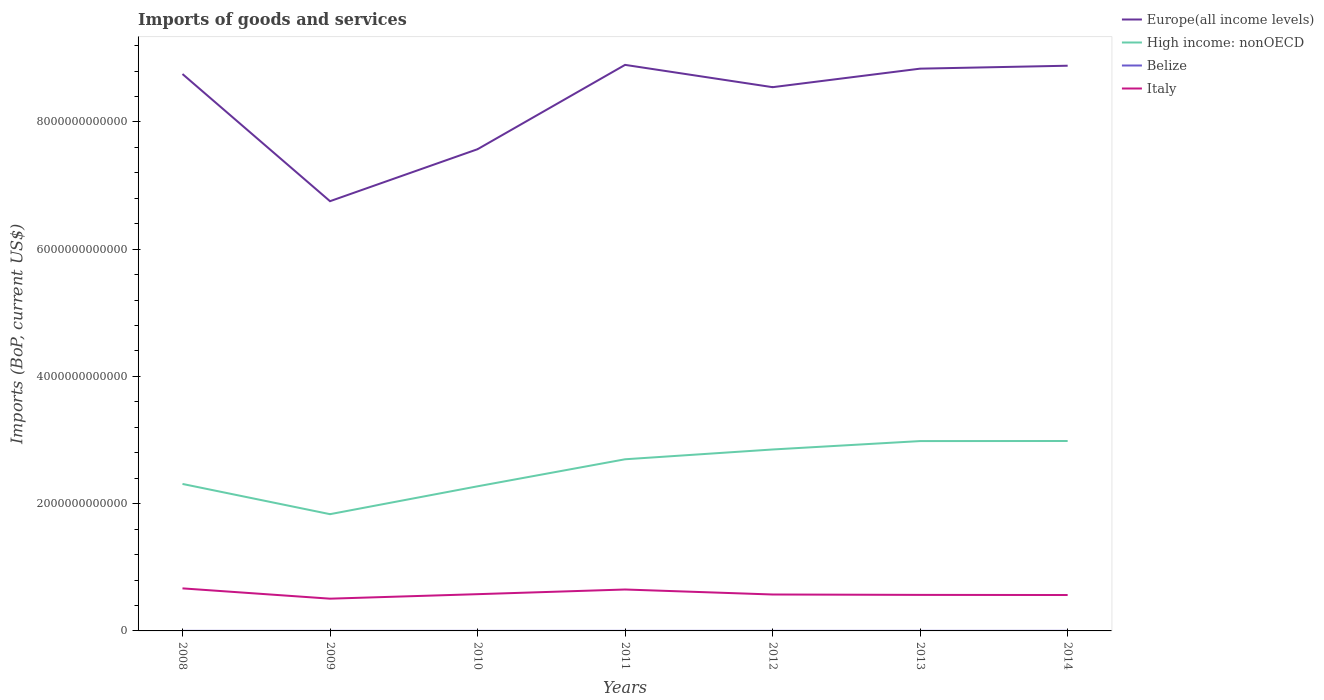Does the line corresponding to High income: nonOECD intersect with the line corresponding to Italy?
Offer a terse response. No. Across all years, what is the maximum amount spent on imports in Belize?
Make the answer very short. 7.82e+08. What is the total amount spent on imports in Belize in the graph?
Provide a succinct answer. -6.72e+07. What is the difference between the highest and the second highest amount spent on imports in High income: nonOECD?
Your answer should be very brief. 1.15e+12. What is the difference between the highest and the lowest amount spent on imports in High income: nonOECD?
Provide a short and direct response. 4. Is the amount spent on imports in High income: nonOECD strictly greater than the amount spent on imports in Italy over the years?
Ensure brevity in your answer.  No. What is the difference between two consecutive major ticks on the Y-axis?
Keep it short and to the point. 2.00e+12. Are the values on the major ticks of Y-axis written in scientific E-notation?
Your answer should be compact. No. Does the graph contain any zero values?
Your answer should be very brief. No. How many legend labels are there?
Give a very brief answer. 4. What is the title of the graph?
Your answer should be compact. Imports of goods and services. Does "East Asia (developing only)" appear as one of the legend labels in the graph?
Your response must be concise. No. What is the label or title of the X-axis?
Provide a short and direct response. Years. What is the label or title of the Y-axis?
Your response must be concise. Imports (BoP, current US$). What is the Imports (BoP, current US$) of Europe(all income levels) in 2008?
Provide a short and direct response. 8.75e+12. What is the Imports (BoP, current US$) of High income: nonOECD in 2008?
Provide a short and direct response. 2.31e+12. What is the Imports (BoP, current US$) in Belize in 2008?
Your answer should be compact. 9.58e+08. What is the Imports (BoP, current US$) of Italy in 2008?
Provide a succinct answer. 6.69e+11. What is the Imports (BoP, current US$) of Europe(all income levels) in 2009?
Your answer should be compact. 6.75e+12. What is the Imports (BoP, current US$) of High income: nonOECD in 2009?
Offer a very short reply. 1.83e+12. What is the Imports (BoP, current US$) of Belize in 2009?
Your answer should be compact. 7.82e+08. What is the Imports (BoP, current US$) of Italy in 2009?
Your response must be concise. 5.07e+11. What is the Imports (BoP, current US$) in Europe(all income levels) in 2010?
Ensure brevity in your answer.  7.57e+12. What is the Imports (BoP, current US$) in High income: nonOECD in 2010?
Provide a short and direct response. 2.27e+12. What is the Imports (BoP, current US$) of Belize in 2010?
Offer a very short reply. 8.10e+08. What is the Imports (BoP, current US$) in Italy in 2010?
Offer a terse response. 5.78e+11. What is the Imports (BoP, current US$) of Europe(all income levels) in 2011?
Keep it short and to the point. 8.90e+12. What is the Imports (BoP, current US$) of High income: nonOECD in 2011?
Keep it short and to the point. 2.70e+12. What is the Imports (BoP, current US$) in Belize in 2011?
Ensure brevity in your answer.  9.49e+08. What is the Imports (BoP, current US$) in Italy in 2011?
Provide a succinct answer. 6.51e+11. What is the Imports (BoP, current US$) in Europe(all income levels) in 2012?
Your answer should be very brief. 8.55e+12. What is the Imports (BoP, current US$) of High income: nonOECD in 2012?
Your answer should be very brief. 2.85e+12. What is the Imports (BoP, current US$) of Belize in 2012?
Make the answer very short. 1.03e+09. What is the Imports (BoP, current US$) of Italy in 2012?
Your answer should be compact. 5.72e+11. What is the Imports (BoP, current US$) of Europe(all income levels) in 2013?
Your answer should be compact. 8.84e+12. What is the Imports (BoP, current US$) in High income: nonOECD in 2013?
Give a very brief answer. 2.98e+12. What is the Imports (BoP, current US$) in Belize in 2013?
Provide a succinct answer. 1.08e+09. What is the Imports (BoP, current US$) in Italy in 2013?
Keep it short and to the point. 5.66e+11. What is the Imports (BoP, current US$) of Europe(all income levels) in 2014?
Your answer should be very brief. 8.88e+12. What is the Imports (BoP, current US$) of High income: nonOECD in 2014?
Offer a very short reply. 2.99e+12. What is the Imports (BoP, current US$) in Belize in 2014?
Your answer should be very brief. 1.15e+09. What is the Imports (BoP, current US$) of Italy in 2014?
Make the answer very short. 5.64e+11. Across all years, what is the maximum Imports (BoP, current US$) of Europe(all income levels)?
Your answer should be compact. 8.90e+12. Across all years, what is the maximum Imports (BoP, current US$) of High income: nonOECD?
Your answer should be compact. 2.99e+12. Across all years, what is the maximum Imports (BoP, current US$) in Belize?
Provide a short and direct response. 1.15e+09. Across all years, what is the maximum Imports (BoP, current US$) of Italy?
Provide a succinct answer. 6.69e+11. Across all years, what is the minimum Imports (BoP, current US$) of Europe(all income levels)?
Give a very brief answer. 6.75e+12. Across all years, what is the minimum Imports (BoP, current US$) of High income: nonOECD?
Ensure brevity in your answer.  1.83e+12. Across all years, what is the minimum Imports (BoP, current US$) in Belize?
Keep it short and to the point. 7.82e+08. Across all years, what is the minimum Imports (BoP, current US$) of Italy?
Your answer should be very brief. 5.07e+11. What is the total Imports (BoP, current US$) of Europe(all income levels) in the graph?
Keep it short and to the point. 5.82e+13. What is the total Imports (BoP, current US$) of High income: nonOECD in the graph?
Provide a short and direct response. 1.79e+13. What is the total Imports (BoP, current US$) in Belize in the graph?
Your answer should be very brief. 6.76e+09. What is the total Imports (BoP, current US$) in Italy in the graph?
Give a very brief answer. 4.11e+12. What is the difference between the Imports (BoP, current US$) of Europe(all income levels) in 2008 and that in 2009?
Your answer should be compact. 2.00e+12. What is the difference between the Imports (BoP, current US$) of High income: nonOECD in 2008 and that in 2009?
Make the answer very short. 4.75e+11. What is the difference between the Imports (BoP, current US$) of Belize in 2008 and that in 2009?
Offer a terse response. 1.76e+08. What is the difference between the Imports (BoP, current US$) in Italy in 2008 and that in 2009?
Provide a succinct answer. 1.62e+11. What is the difference between the Imports (BoP, current US$) in Europe(all income levels) in 2008 and that in 2010?
Make the answer very short. 1.18e+12. What is the difference between the Imports (BoP, current US$) of High income: nonOECD in 2008 and that in 2010?
Your answer should be very brief. 3.72e+1. What is the difference between the Imports (BoP, current US$) of Belize in 2008 and that in 2010?
Offer a very short reply. 1.48e+08. What is the difference between the Imports (BoP, current US$) of Italy in 2008 and that in 2010?
Provide a short and direct response. 9.11e+1. What is the difference between the Imports (BoP, current US$) of Europe(all income levels) in 2008 and that in 2011?
Give a very brief answer. -1.44e+11. What is the difference between the Imports (BoP, current US$) in High income: nonOECD in 2008 and that in 2011?
Your answer should be compact. -3.88e+11. What is the difference between the Imports (BoP, current US$) of Belize in 2008 and that in 2011?
Offer a very short reply. 8.56e+06. What is the difference between the Imports (BoP, current US$) in Italy in 2008 and that in 2011?
Offer a terse response. 1.76e+1. What is the difference between the Imports (BoP, current US$) in Europe(all income levels) in 2008 and that in 2012?
Your response must be concise. 2.07e+11. What is the difference between the Imports (BoP, current US$) in High income: nonOECD in 2008 and that in 2012?
Your response must be concise. -5.41e+11. What is the difference between the Imports (BoP, current US$) of Belize in 2008 and that in 2012?
Your answer should be very brief. -6.72e+07. What is the difference between the Imports (BoP, current US$) in Italy in 2008 and that in 2012?
Provide a succinct answer. 9.64e+1. What is the difference between the Imports (BoP, current US$) of Europe(all income levels) in 2008 and that in 2013?
Your answer should be very brief. -8.43e+1. What is the difference between the Imports (BoP, current US$) of High income: nonOECD in 2008 and that in 2013?
Provide a short and direct response. -6.74e+11. What is the difference between the Imports (BoP, current US$) in Belize in 2008 and that in 2013?
Give a very brief answer. -1.26e+08. What is the difference between the Imports (BoP, current US$) in Italy in 2008 and that in 2013?
Provide a succinct answer. 1.02e+11. What is the difference between the Imports (BoP, current US$) of Europe(all income levels) in 2008 and that in 2014?
Keep it short and to the point. -1.30e+11. What is the difference between the Imports (BoP, current US$) in High income: nonOECD in 2008 and that in 2014?
Offer a very short reply. -6.75e+11. What is the difference between the Imports (BoP, current US$) of Belize in 2008 and that in 2014?
Offer a terse response. -1.92e+08. What is the difference between the Imports (BoP, current US$) in Italy in 2008 and that in 2014?
Keep it short and to the point. 1.04e+11. What is the difference between the Imports (BoP, current US$) of Europe(all income levels) in 2009 and that in 2010?
Provide a short and direct response. -8.17e+11. What is the difference between the Imports (BoP, current US$) in High income: nonOECD in 2009 and that in 2010?
Provide a short and direct response. -4.38e+11. What is the difference between the Imports (BoP, current US$) in Belize in 2009 and that in 2010?
Your answer should be compact. -2.74e+07. What is the difference between the Imports (BoP, current US$) of Italy in 2009 and that in 2010?
Give a very brief answer. -7.07e+1. What is the difference between the Imports (BoP, current US$) of Europe(all income levels) in 2009 and that in 2011?
Keep it short and to the point. -2.14e+12. What is the difference between the Imports (BoP, current US$) in High income: nonOECD in 2009 and that in 2011?
Your answer should be compact. -8.63e+11. What is the difference between the Imports (BoP, current US$) in Belize in 2009 and that in 2011?
Offer a terse response. -1.67e+08. What is the difference between the Imports (BoP, current US$) in Italy in 2009 and that in 2011?
Your answer should be compact. -1.44e+11. What is the difference between the Imports (BoP, current US$) of Europe(all income levels) in 2009 and that in 2012?
Offer a terse response. -1.79e+12. What is the difference between the Imports (BoP, current US$) in High income: nonOECD in 2009 and that in 2012?
Your answer should be very brief. -1.02e+12. What is the difference between the Imports (BoP, current US$) in Belize in 2009 and that in 2012?
Provide a succinct answer. -2.43e+08. What is the difference between the Imports (BoP, current US$) in Italy in 2009 and that in 2012?
Your answer should be compact. -6.54e+1. What is the difference between the Imports (BoP, current US$) of Europe(all income levels) in 2009 and that in 2013?
Ensure brevity in your answer.  -2.08e+12. What is the difference between the Imports (BoP, current US$) of High income: nonOECD in 2009 and that in 2013?
Your answer should be very brief. -1.15e+12. What is the difference between the Imports (BoP, current US$) of Belize in 2009 and that in 2013?
Ensure brevity in your answer.  -3.01e+08. What is the difference between the Imports (BoP, current US$) in Italy in 2009 and that in 2013?
Ensure brevity in your answer.  -5.94e+1. What is the difference between the Imports (BoP, current US$) of Europe(all income levels) in 2009 and that in 2014?
Your answer should be very brief. -2.13e+12. What is the difference between the Imports (BoP, current US$) in High income: nonOECD in 2009 and that in 2014?
Provide a succinct answer. -1.15e+12. What is the difference between the Imports (BoP, current US$) in Belize in 2009 and that in 2014?
Give a very brief answer. -3.68e+08. What is the difference between the Imports (BoP, current US$) of Italy in 2009 and that in 2014?
Provide a succinct answer. -5.75e+1. What is the difference between the Imports (BoP, current US$) of Europe(all income levels) in 2010 and that in 2011?
Offer a terse response. -1.33e+12. What is the difference between the Imports (BoP, current US$) in High income: nonOECD in 2010 and that in 2011?
Your response must be concise. -4.25e+11. What is the difference between the Imports (BoP, current US$) of Belize in 2010 and that in 2011?
Ensure brevity in your answer.  -1.40e+08. What is the difference between the Imports (BoP, current US$) in Italy in 2010 and that in 2011?
Offer a terse response. -7.35e+1. What is the difference between the Imports (BoP, current US$) in Europe(all income levels) in 2010 and that in 2012?
Ensure brevity in your answer.  -9.75e+11. What is the difference between the Imports (BoP, current US$) of High income: nonOECD in 2010 and that in 2012?
Offer a terse response. -5.79e+11. What is the difference between the Imports (BoP, current US$) in Belize in 2010 and that in 2012?
Your answer should be compact. -2.15e+08. What is the difference between the Imports (BoP, current US$) of Italy in 2010 and that in 2012?
Ensure brevity in your answer.  5.26e+09. What is the difference between the Imports (BoP, current US$) in Europe(all income levels) in 2010 and that in 2013?
Your response must be concise. -1.27e+12. What is the difference between the Imports (BoP, current US$) of High income: nonOECD in 2010 and that in 2013?
Your answer should be compact. -7.11e+11. What is the difference between the Imports (BoP, current US$) of Belize in 2010 and that in 2013?
Provide a succinct answer. -2.74e+08. What is the difference between the Imports (BoP, current US$) of Italy in 2010 and that in 2013?
Keep it short and to the point. 1.13e+1. What is the difference between the Imports (BoP, current US$) of Europe(all income levels) in 2010 and that in 2014?
Your answer should be compact. -1.31e+12. What is the difference between the Imports (BoP, current US$) of High income: nonOECD in 2010 and that in 2014?
Your answer should be very brief. -7.12e+11. What is the difference between the Imports (BoP, current US$) of Belize in 2010 and that in 2014?
Offer a very short reply. -3.41e+08. What is the difference between the Imports (BoP, current US$) in Italy in 2010 and that in 2014?
Offer a terse response. 1.32e+1. What is the difference between the Imports (BoP, current US$) of Europe(all income levels) in 2011 and that in 2012?
Your answer should be compact. 3.51e+11. What is the difference between the Imports (BoP, current US$) of High income: nonOECD in 2011 and that in 2012?
Offer a terse response. -1.54e+11. What is the difference between the Imports (BoP, current US$) of Belize in 2011 and that in 2012?
Your answer should be compact. -7.58e+07. What is the difference between the Imports (BoP, current US$) in Italy in 2011 and that in 2012?
Your answer should be very brief. 7.88e+1. What is the difference between the Imports (BoP, current US$) in Europe(all income levels) in 2011 and that in 2013?
Make the answer very short. 5.94e+1. What is the difference between the Imports (BoP, current US$) in High income: nonOECD in 2011 and that in 2013?
Give a very brief answer. -2.86e+11. What is the difference between the Imports (BoP, current US$) in Belize in 2011 and that in 2013?
Your response must be concise. -1.34e+08. What is the difference between the Imports (BoP, current US$) of Italy in 2011 and that in 2013?
Your answer should be compact. 8.48e+1. What is the difference between the Imports (BoP, current US$) of Europe(all income levels) in 2011 and that in 2014?
Offer a terse response. 1.32e+1. What is the difference between the Imports (BoP, current US$) in High income: nonOECD in 2011 and that in 2014?
Your response must be concise. -2.87e+11. What is the difference between the Imports (BoP, current US$) in Belize in 2011 and that in 2014?
Make the answer very short. -2.01e+08. What is the difference between the Imports (BoP, current US$) in Italy in 2011 and that in 2014?
Provide a succinct answer. 8.67e+1. What is the difference between the Imports (BoP, current US$) of Europe(all income levels) in 2012 and that in 2013?
Keep it short and to the point. -2.91e+11. What is the difference between the Imports (BoP, current US$) of High income: nonOECD in 2012 and that in 2013?
Your response must be concise. -1.32e+11. What is the difference between the Imports (BoP, current US$) in Belize in 2012 and that in 2013?
Provide a succinct answer. -5.86e+07. What is the difference between the Imports (BoP, current US$) of Italy in 2012 and that in 2013?
Keep it short and to the point. 6.00e+09. What is the difference between the Imports (BoP, current US$) of Europe(all income levels) in 2012 and that in 2014?
Your response must be concise. -3.37e+11. What is the difference between the Imports (BoP, current US$) of High income: nonOECD in 2012 and that in 2014?
Provide a succinct answer. -1.33e+11. What is the difference between the Imports (BoP, current US$) of Belize in 2012 and that in 2014?
Ensure brevity in your answer.  -1.25e+08. What is the difference between the Imports (BoP, current US$) of Italy in 2012 and that in 2014?
Offer a very short reply. 7.92e+09. What is the difference between the Imports (BoP, current US$) in Europe(all income levels) in 2013 and that in 2014?
Ensure brevity in your answer.  -4.62e+1. What is the difference between the Imports (BoP, current US$) of High income: nonOECD in 2013 and that in 2014?
Your answer should be compact. -1.19e+09. What is the difference between the Imports (BoP, current US$) of Belize in 2013 and that in 2014?
Your response must be concise. -6.64e+07. What is the difference between the Imports (BoP, current US$) of Italy in 2013 and that in 2014?
Keep it short and to the point. 1.92e+09. What is the difference between the Imports (BoP, current US$) of Europe(all income levels) in 2008 and the Imports (BoP, current US$) of High income: nonOECD in 2009?
Your response must be concise. 6.92e+12. What is the difference between the Imports (BoP, current US$) of Europe(all income levels) in 2008 and the Imports (BoP, current US$) of Belize in 2009?
Provide a succinct answer. 8.75e+12. What is the difference between the Imports (BoP, current US$) of Europe(all income levels) in 2008 and the Imports (BoP, current US$) of Italy in 2009?
Provide a short and direct response. 8.25e+12. What is the difference between the Imports (BoP, current US$) in High income: nonOECD in 2008 and the Imports (BoP, current US$) in Belize in 2009?
Your answer should be very brief. 2.31e+12. What is the difference between the Imports (BoP, current US$) in High income: nonOECD in 2008 and the Imports (BoP, current US$) in Italy in 2009?
Your response must be concise. 1.80e+12. What is the difference between the Imports (BoP, current US$) in Belize in 2008 and the Imports (BoP, current US$) in Italy in 2009?
Give a very brief answer. -5.06e+11. What is the difference between the Imports (BoP, current US$) in Europe(all income levels) in 2008 and the Imports (BoP, current US$) in High income: nonOECD in 2010?
Give a very brief answer. 6.48e+12. What is the difference between the Imports (BoP, current US$) in Europe(all income levels) in 2008 and the Imports (BoP, current US$) in Belize in 2010?
Offer a terse response. 8.75e+12. What is the difference between the Imports (BoP, current US$) of Europe(all income levels) in 2008 and the Imports (BoP, current US$) of Italy in 2010?
Your answer should be compact. 8.18e+12. What is the difference between the Imports (BoP, current US$) of High income: nonOECD in 2008 and the Imports (BoP, current US$) of Belize in 2010?
Provide a succinct answer. 2.31e+12. What is the difference between the Imports (BoP, current US$) in High income: nonOECD in 2008 and the Imports (BoP, current US$) in Italy in 2010?
Provide a succinct answer. 1.73e+12. What is the difference between the Imports (BoP, current US$) in Belize in 2008 and the Imports (BoP, current US$) in Italy in 2010?
Your answer should be compact. -5.77e+11. What is the difference between the Imports (BoP, current US$) of Europe(all income levels) in 2008 and the Imports (BoP, current US$) of High income: nonOECD in 2011?
Your response must be concise. 6.06e+12. What is the difference between the Imports (BoP, current US$) of Europe(all income levels) in 2008 and the Imports (BoP, current US$) of Belize in 2011?
Provide a succinct answer. 8.75e+12. What is the difference between the Imports (BoP, current US$) of Europe(all income levels) in 2008 and the Imports (BoP, current US$) of Italy in 2011?
Your response must be concise. 8.10e+12. What is the difference between the Imports (BoP, current US$) of High income: nonOECD in 2008 and the Imports (BoP, current US$) of Belize in 2011?
Offer a terse response. 2.31e+12. What is the difference between the Imports (BoP, current US$) of High income: nonOECD in 2008 and the Imports (BoP, current US$) of Italy in 2011?
Your answer should be compact. 1.66e+12. What is the difference between the Imports (BoP, current US$) of Belize in 2008 and the Imports (BoP, current US$) of Italy in 2011?
Offer a very short reply. -6.50e+11. What is the difference between the Imports (BoP, current US$) in Europe(all income levels) in 2008 and the Imports (BoP, current US$) in High income: nonOECD in 2012?
Provide a short and direct response. 5.90e+12. What is the difference between the Imports (BoP, current US$) in Europe(all income levels) in 2008 and the Imports (BoP, current US$) in Belize in 2012?
Your answer should be very brief. 8.75e+12. What is the difference between the Imports (BoP, current US$) in Europe(all income levels) in 2008 and the Imports (BoP, current US$) in Italy in 2012?
Give a very brief answer. 8.18e+12. What is the difference between the Imports (BoP, current US$) in High income: nonOECD in 2008 and the Imports (BoP, current US$) in Belize in 2012?
Keep it short and to the point. 2.31e+12. What is the difference between the Imports (BoP, current US$) of High income: nonOECD in 2008 and the Imports (BoP, current US$) of Italy in 2012?
Your answer should be compact. 1.74e+12. What is the difference between the Imports (BoP, current US$) in Belize in 2008 and the Imports (BoP, current US$) in Italy in 2012?
Your response must be concise. -5.71e+11. What is the difference between the Imports (BoP, current US$) of Europe(all income levels) in 2008 and the Imports (BoP, current US$) of High income: nonOECD in 2013?
Provide a short and direct response. 5.77e+12. What is the difference between the Imports (BoP, current US$) in Europe(all income levels) in 2008 and the Imports (BoP, current US$) in Belize in 2013?
Your answer should be very brief. 8.75e+12. What is the difference between the Imports (BoP, current US$) of Europe(all income levels) in 2008 and the Imports (BoP, current US$) of Italy in 2013?
Keep it short and to the point. 8.19e+12. What is the difference between the Imports (BoP, current US$) in High income: nonOECD in 2008 and the Imports (BoP, current US$) in Belize in 2013?
Your response must be concise. 2.31e+12. What is the difference between the Imports (BoP, current US$) of High income: nonOECD in 2008 and the Imports (BoP, current US$) of Italy in 2013?
Offer a very short reply. 1.74e+12. What is the difference between the Imports (BoP, current US$) in Belize in 2008 and the Imports (BoP, current US$) in Italy in 2013?
Keep it short and to the point. -5.65e+11. What is the difference between the Imports (BoP, current US$) in Europe(all income levels) in 2008 and the Imports (BoP, current US$) in High income: nonOECD in 2014?
Keep it short and to the point. 5.77e+12. What is the difference between the Imports (BoP, current US$) in Europe(all income levels) in 2008 and the Imports (BoP, current US$) in Belize in 2014?
Your answer should be very brief. 8.75e+12. What is the difference between the Imports (BoP, current US$) in Europe(all income levels) in 2008 and the Imports (BoP, current US$) in Italy in 2014?
Offer a terse response. 8.19e+12. What is the difference between the Imports (BoP, current US$) in High income: nonOECD in 2008 and the Imports (BoP, current US$) in Belize in 2014?
Provide a short and direct response. 2.31e+12. What is the difference between the Imports (BoP, current US$) of High income: nonOECD in 2008 and the Imports (BoP, current US$) of Italy in 2014?
Make the answer very short. 1.75e+12. What is the difference between the Imports (BoP, current US$) in Belize in 2008 and the Imports (BoP, current US$) in Italy in 2014?
Provide a short and direct response. -5.63e+11. What is the difference between the Imports (BoP, current US$) in Europe(all income levels) in 2009 and the Imports (BoP, current US$) in High income: nonOECD in 2010?
Keep it short and to the point. 4.48e+12. What is the difference between the Imports (BoP, current US$) of Europe(all income levels) in 2009 and the Imports (BoP, current US$) of Belize in 2010?
Provide a short and direct response. 6.75e+12. What is the difference between the Imports (BoP, current US$) in Europe(all income levels) in 2009 and the Imports (BoP, current US$) in Italy in 2010?
Your answer should be very brief. 6.18e+12. What is the difference between the Imports (BoP, current US$) in High income: nonOECD in 2009 and the Imports (BoP, current US$) in Belize in 2010?
Keep it short and to the point. 1.83e+12. What is the difference between the Imports (BoP, current US$) in High income: nonOECD in 2009 and the Imports (BoP, current US$) in Italy in 2010?
Offer a very short reply. 1.26e+12. What is the difference between the Imports (BoP, current US$) of Belize in 2009 and the Imports (BoP, current US$) of Italy in 2010?
Keep it short and to the point. -5.77e+11. What is the difference between the Imports (BoP, current US$) in Europe(all income levels) in 2009 and the Imports (BoP, current US$) in High income: nonOECD in 2011?
Ensure brevity in your answer.  4.06e+12. What is the difference between the Imports (BoP, current US$) of Europe(all income levels) in 2009 and the Imports (BoP, current US$) of Belize in 2011?
Offer a very short reply. 6.75e+12. What is the difference between the Imports (BoP, current US$) in Europe(all income levels) in 2009 and the Imports (BoP, current US$) in Italy in 2011?
Your response must be concise. 6.10e+12. What is the difference between the Imports (BoP, current US$) in High income: nonOECD in 2009 and the Imports (BoP, current US$) in Belize in 2011?
Your answer should be very brief. 1.83e+12. What is the difference between the Imports (BoP, current US$) of High income: nonOECD in 2009 and the Imports (BoP, current US$) of Italy in 2011?
Offer a terse response. 1.18e+12. What is the difference between the Imports (BoP, current US$) in Belize in 2009 and the Imports (BoP, current US$) in Italy in 2011?
Give a very brief answer. -6.50e+11. What is the difference between the Imports (BoP, current US$) of Europe(all income levels) in 2009 and the Imports (BoP, current US$) of High income: nonOECD in 2012?
Offer a very short reply. 3.90e+12. What is the difference between the Imports (BoP, current US$) in Europe(all income levels) in 2009 and the Imports (BoP, current US$) in Belize in 2012?
Give a very brief answer. 6.75e+12. What is the difference between the Imports (BoP, current US$) in Europe(all income levels) in 2009 and the Imports (BoP, current US$) in Italy in 2012?
Give a very brief answer. 6.18e+12. What is the difference between the Imports (BoP, current US$) in High income: nonOECD in 2009 and the Imports (BoP, current US$) in Belize in 2012?
Provide a short and direct response. 1.83e+12. What is the difference between the Imports (BoP, current US$) in High income: nonOECD in 2009 and the Imports (BoP, current US$) in Italy in 2012?
Ensure brevity in your answer.  1.26e+12. What is the difference between the Imports (BoP, current US$) in Belize in 2009 and the Imports (BoP, current US$) in Italy in 2012?
Make the answer very short. -5.72e+11. What is the difference between the Imports (BoP, current US$) of Europe(all income levels) in 2009 and the Imports (BoP, current US$) of High income: nonOECD in 2013?
Offer a terse response. 3.77e+12. What is the difference between the Imports (BoP, current US$) of Europe(all income levels) in 2009 and the Imports (BoP, current US$) of Belize in 2013?
Keep it short and to the point. 6.75e+12. What is the difference between the Imports (BoP, current US$) in Europe(all income levels) in 2009 and the Imports (BoP, current US$) in Italy in 2013?
Your answer should be compact. 6.19e+12. What is the difference between the Imports (BoP, current US$) in High income: nonOECD in 2009 and the Imports (BoP, current US$) in Belize in 2013?
Make the answer very short. 1.83e+12. What is the difference between the Imports (BoP, current US$) in High income: nonOECD in 2009 and the Imports (BoP, current US$) in Italy in 2013?
Offer a terse response. 1.27e+12. What is the difference between the Imports (BoP, current US$) of Belize in 2009 and the Imports (BoP, current US$) of Italy in 2013?
Provide a short and direct response. -5.66e+11. What is the difference between the Imports (BoP, current US$) in Europe(all income levels) in 2009 and the Imports (BoP, current US$) in High income: nonOECD in 2014?
Your answer should be very brief. 3.77e+12. What is the difference between the Imports (BoP, current US$) in Europe(all income levels) in 2009 and the Imports (BoP, current US$) in Belize in 2014?
Your response must be concise. 6.75e+12. What is the difference between the Imports (BoP, current US$) of Europe(all income levels) in 2009 and the Imports (BoP, current US$) of Italy in 2014?
Provide a succinct answer. 6.19e+12. What is the difference between the Imports (BoP, current US$) in High income: nonOECD in 2009 and the Imports (BoP, current US$) in Belize in 2014?
Offer a terse response. 1.83e+12. What is the difference between the Imports (BoP, current US$) in High income: nonOECD in 2009 and the Imports (BoP, current US$) in Italy in 2014?
Give a very brief answer. 1.27e+12. What is the difference between the Imports (BoP, current US$) of Belize in 2009 and the Imports (BoP, current US$) of Italy in 2014?
Your response must be concise. -5.64e+11. What is the difference between the Imports (BoP, current US$) in Europe(all income levels) in 2010 and the Imports (BoP, current US$) in High income: nonOECD in 2011?
Your response must be concise. 4.87e+12. What is the difference between the Imports (BoP, current US$) of Europe(all income levels) in 2010 and the Imports (BoP, current US$) of Belize in 2011?
Make the answer very short. 7.57e+12. What is the difference between the Imports (BoP, current US$) of Europe(all income levels) in 2010 and the Imports (BoP, current US$) of Italy in 2011?
Ensure brevity in your answer.  6.92e+12. What is the difference between the Imports (BoP, current US$) of High income: nonOECD in 2010 and the Imports (BoP, current US$) of Belize in 2011?
Your answer should be very brief. 2.27e+12. What is the difference between the Imports (BoP, current US$) in High income: nonOECD in 2010 and the Imports (BoP, current US$) in Italy in 2011?
Keep it short and to the point. 1.62e+12. What is the difference between the Imports (BoP, current US$) in Belize in 2010 and the Imports (BoP, current US$) in Italy in 2011?
Provide a short and direct response. -6.50e+11. What is the difference between the Imports (BoP, current US$) in Europe(all income levels) in 2010 and the Imports (BoP, current US$) in High income: nonOECD in 2012?
Provide a short and direct response. 4.72e+12. What is the difference between the Imports (BoP, current US$) of Europe(all income levels) in 2010 and the Imports (BoP, current US$) of Belize in 2012?
Offer a terse response. 7.57e+12. What is the difference between the Imports (BoP, current US$) of Europe(all income levels) in 2010 and the Imports (BoP, current US$) of Italy in 2012?
Your answer should be compact. 7.00e+12. What is the difference between the Imports (BoP, current US$) of High income: nonOECD in 2010 and the Imports (BoP, current US$) of Belize in 2012?
Your answer should be very brief. 2.27e+12. What is the difference between the Imports (BoP, current US$) of High income: nonOECD in 2010 and the Imports (BoP, current US$) of Italy in 2012?
Your answer should be very brief. 1.70e+12. What is the difference between the Imports (BoP, current US$) in Belize in 2010 and the Imports (BoP, current US$) in Italy in 2012?
Give a very brief answer. -5.72e+11. What is the difference between the Imports (BoP, current US$) in Europe(all income levels) in 2010 and the Imports (BoP, current US$) in High income: nonOECD in 2013?
Keep it short and to the point. 4.59e+12. What is the difference between the Imports (BoP, current US$) in Europe(all income levels) in 2010 and the Imports (BoP, current US$) in Belize in 2013?
Your answer should be very brief. 7.57e+12. What is the difference between the Imports (BoP, current US$) of Europe(all income levels) in 2010 and the Imports (BoP, current US$) of Italy in 2013?
Your response must be concise. 7.00e+12. What is the difference between the Imports (BoP, current US$) in High income: nonOECD in 2010 and the Imports (BoP, current US$) in Belize in 2013?
Make the answer very short. 2.27e+12. What is the difference between the Imports (BoP, current US$) in High income: nonOECD in 2010 and the Imports (BoP, current US$) in Italy in 2013?
Provide a succinct answer. 1.71e+12. What is the difference between the Imports (BoP, current US$) in Belize in 2010 and the Imports (BoP, current US$) in Italy in 2013?
Keep it short and to the point. -5.66e+11. What is the difference between the Imports (BoP, current US$) of Europe(all income levels) in 2010 and the Imports (BoP, current US$) of High income: nonOECD in 2014?
Ensure brevity in your answer.  4.59e+12. What is the difference between the Imports (BoP, current US$) of Europe(all income levels) in 2010 and the Imports (BoP, current US$) of Belize in 2014?
Your answer should be compact. 7.57e+12. What is the difference between the Imports (BoP, current US$) in Europe(all income levels) in 2010 and the Imports (BoP, current US$) in Italy in 2014?
Your response must be concise. 7.01e+12. What is the difference between the Imports (BoP, current US$) in High income: nonOECD in 2010 and the Imports (BoP, current US$) in Belize in 2014?
Offer a very short reply. 2.27e+12. What is the difference between the Imports (BoP, current US$) in High income: nonOECD in 2010 and the Imports (BoP, current US$) in Italy in 2014?
Offer a terse response. 1.71e+12. What is the difference between the Imports (BoP, current US$) of Belize in 2010 and the Imports (BoP, current US$) of Italy in 2014?
Your answer should be very brief. -5.64e+11. What is the difference between the Imports (BoP, current US$) of Europe(all income levels) in 2011 and the Imports (BoP, current US$) of High income: nonOECD in 2012?
Offer a very short reply. 6.05e+12. What is the difference between the Imports (BoP, current US$) of Europe(all income levels) in 2011 and the Imports (BoP, current US$) of Belize in 2012?
Ensure brevity in your answer.  8.90e+12. What is the difference between the Imports (BoP, current US$) of Europe(all income levels) in 2011 and the Imports (BoP, current US$) of Italy in 2012?
Give a very brief answer. 8.32e+12. What is the difference between the Imports (BoP, current US$) in High income: nonOECD in 2011 and the Imports (BoP, current US$) in Belize in 2012?
Provide a short and direct response. 2.70e+12. What is the difference between the Imports (BoP, current US$) in High income: nonOECD in 2011 and the Imports (BoP, current US$) in Italy in 2012?
Ensure brevity in your answer.  2.13e+12. What is the difference between the Imports (BoP, current US$) of Belize in 2011 and the Imports (BoP, current US$) of Italy in 2012?
Give a very brief answer. -5.71e+11. What is the difference between the Imports (BoP, current US$) of Europe(all income levels) in 2011 and the Imports (BoP, current US$) of High income: nonOECD in 2013?
Make the answer very short. 5.91e+12. What is the difference between the Imports (BoP, current US$) in Europe(all income levels) in 2011 and the Imports (BoP, current US$) in Belize in 2013?
Make the answer very short. 8.90e+12. What is the difference between the Imports (BoP, current US$) in Europe(all income levels) in 2011 and the Imports (BoP, current US$) in Italy in 2013?
Offer a terse response. 8.33e+12. What is the difference between the Imports (BoP, current US$) in High income: nonOECD in 2011 and the Imports (BoP, current US$) in Belize in 2013?
Your response must be concise. 2.70e+12. What is the difference between the Imports (BoP, current US$) of High income: nonOECD in 2011 and the Imports (BoP, current US$) of Italy in 2013?
Give a very brief answer. 2.13e+12. What is the difference between the Imports (BoP, current US$) in Belize in 2011 and the Imports (BoP, current US$) in Italy in 2013?
Keep it short and to the point. -5.65e+11. What is the difference between the Imports (BoP, current US$) in Europe(all income levels) in 2011 and the Imports (BoP, current US$) in High income: nonOECD in 2014?
Provide a short and direct response. 5.91e+12. What is the difference between the Imports (BoP, current US$) of Europe(all income levels) in 2011 and the Imports (BoP, current US$) of Belize in 2014?
Make the answer very short. 8.90e+12. What is the difference between the Imports (BoP, current US$) of Europe(all income levels) in 2011 and the Imports (BoP, current US$) of Italy in 2014?
Provide a short and direct response. 8.33e+12. What is the difference between the Imports (BoP, current US$) in High income: nonOECD in 2011 and the Imports (BoP, current US$) in Belize in 2014?
Your answer should be very brief. 2.70e+12. What is the difference between the Imports (BoP, current US$) of High income: nonOECD in 2011 and the Imports (BoP, current US$) of Italy in 2014?
Your answer should be very brief. 2.13e+12. What is the difference between the Imports (BoP, current US$) in Belize in 2011 and the Imports (BoP, current US$) in Italy in 2014?
Give a very brief answer. -5.63e+11. What is the difference between the Imports (BoP, current US$) of Europe(all income levels) in 2012 and the Imports (BoP, current US$) of High income: nonOECD in 2013?
Provide a short and direct response. 5.56e+12. What is the difference between the Imports (BoP, current US$) in Europe(all income levels) in 2012 and the Imports (BoP, current US$) in Belize in 2013?
Your response must be concise. 8.55e+12. What is the difference between the Imports (BoP, current US$) of Europe(all income levels) in 2012 and the Imports (BoP, current US$) of Italy in 2013?
Provide a succinct answer. 7.98e+12. What is the difference between the Imports (BoP, current US$) of High income: nonOECD in 2012 and the Imports (BoP, current US$) of Belize in 2013?
Provide a short and direct response. 2.85e+12. What is the difference between the Imports (BoP, current US$) in High income: nonOECD in 2012 and the Imports (BoP, current US$) in Italy in 2013?
Provide a succinct answer. 2.29e+12. What is the difference between the Imports (BoP, current US$) of Belize in 2012 and the Imports (BoP, current US$) of Italy in 2013?
Your answer should be very brief. -5.65e+11. What is the difference between the Imports (BoP, current US$) in Europe(all income levels) in 2012 and the Imports (BoP, current US$) in High income: nonOECD in 2014?
Your response must be concise. 5.56e+12. What is the difference between the Imports (BoP, current US$) of Europe(all income levels) in 2012 and the Imports (BoP, current US$) of Belize in 2014?
Make the answer very short. 8.54e+12. What is the difference between the Imports (BoP, current US$) in Europe(all income levels) in 2012 and the Imports (BoP, current US$) in Italy in 2014?
Offer a terse response. 7.98e+12. What is the difference between the Imports (BoP, current US$) of High income: nonOECD in 2012 and the Imports (BoP, current US$) of Belize in 2014?
Provide a succinct answer. 2.85e+12. What is the difference between the Imports (BoP, current US$) of High income: nonOECD in 2012 and the Imports (BoP, current US$) of Italy in 2014?
Provide a short and direct response. 2.29e+12. What is the difference between the Imports (BoP, current US$) of Belize in 2012 and the Imports (BoP, current US$) of Italy in 2014?
Offer a very short reply. -5.63e+11. What is the difference between the Imports (BoP, current US$) in Europe(all income levels) in 2013 and the Imports (BoP, current US$) in High income: nonOECD in 2014?
Provide a short and direct response. 5.85e+12. What is the difference between the Imports (BoP, current US$) of Europe(all income levels) in 2013 and the Imports (BoP, current US$) of Belize in 2014?
Your response must be concise. 8.84e+12. What is the difference between the Imports (BoP, current US$) in Europe(all income levels) in 2013 and the Imports (BoP, current US$) in Italy in 2014?
Offer a very short reply. 8.27e+12. What is the difference between the Imports (BoP, current US$) of High income: nonOECD in 2013 and the Imports (BoP, current US$) of Belize in 2014?
Provide a succinct answer. 2.98e+12. What is the difference between the Imports (BoP, current US$) of High income: nonOECD in 2013 and the Imports (BoP, current US$) of Italy in 2014?
Keep it short and to the point. 2.42e+12. What is the difference between the Imports (BoP, current US$) of Belize in 2013 and the Imports (BoP, current US$) of Italy in 2014?
Keep it short and to the point. -5.63e+11. What is the average Imports (BoP, current US$) in Europe(all income levels) per year?
Your answer should be compact. 8.32e+12. What is the average Imports (BoP, current US$) in High income: nonOECD per year?
Give a very brief answer. 2.56e+12. What is the average Imports (BoP, current US$) of Belize per year?
Provide a succinct answer. 9.65e+08. What is the average Imports (BoP, current US$) of Italy per year?
Offer a terse response. 5.87e+11. In the year 2008, what is the difference between the Imports (BoP, current US$) in Europe(all income levels) and Imports (BoP, current US$) in High income: nonOECD?
Offer a very short reply. 6.44e+12. In the year 2008, what is the difference between the Imports (BoP, current US$) of Europe(all income levels) and Imports (BoP, current US$) of Belize?
Give a very brief answer. 8.75e+12. In the year 2008, what is the difference between the Imports (BoP, current US$) in Europe(all income levels) and Imports (BoP, current US$) in Italy?
Your answer should be very brief. 8.08e+12. In the year 2008, what is the difference between the Imports (BoP, current US$) in High income: nonOECD and Imports (BoP, current US$) in Belize?
Offer a terse response. 2.31e+12. In the year 2008, what is the difference between the Imports (BoP, current US$) of High income: nonOECD and Imports (BoP, current US$) of Italy?
Provide a succinct answer. 1.64e+12. In the year 2008, what is the difference between the Imports (BoP, current US$) of Belize and Imports (BoP, current US$) of Italy?
Provide a succinct answer. -6.68e+11. In the year 2009, what is the difference between the Imports (BoP, current US$) of Europe(all income levels) and Imports (BoP, current US$) of High income: nonOECD?
Your answer should be very brief. 4.92e+12. In the year 2009, what is the difference between the Imports (BoP, current US$) in Europe(all income levels) and Imports (BoP, current US$) in Belize?
Your response must be concise. 6.75e+12. In the year 2009, what is the difference between the Imports (BoP, current US$) of Europe(all income levels) and Imports (BoP, current US$) of Italy?
Your response must be concise. 6.25e+12. In the year 2009, what is the difference between the Imports (BoP, current US$) in High income: nonOECD and Imports (BoP, current US$) in Belize?
Offer a terse response. 1.83e+12. In the year 2009, what is the difference between the Imports (BoP, current US$) in High income: nonOECD and Imports (BoP, current US$) in Italy?
Offer a terse response. 1.33e+12. In the year 2009, what is the difference between the Imports (BoP, current US$) in Belize and Imports (BoP, current US$) in Italy?
Offer a terse response. -5.06e+11. In the year 2010, what is the difference between the Imports (BoP, current US$) in Europe(all income levels) and Imports (BoP, current US$) in High income: nonOECD?
Provide a short and direct response. 5.30e+12. In the year 2010, what is the difference between the Imports (BoP, current US$) of Europe(all income levels) and Imports (BoP, current US$) of Belize?
Make the answer very short. 7.57e+12. In the year 2010, what is the difference between the Imports (BoP, current US$) in Europe(all income levels) and Imports (BoP, current US$) in Italy?
Your answer should be compact. 6.99e+12. In the year 2010, what is the difference between the Imports (BoP, current US$) in High income: nonOECD and Imports (BoP, current US$) in Belize?
Offer a terse response. 2.27e+12. In the year 2010, what is the difference between the Imports (BoP, current US$) of High income: nonOECD and Imports (BoP, current US$) of Italy?
Your response must be concise. 1.70e+12. In the year 2010, what is the difference between the Imports (BoP, current US$) in Belize and Imports (BoP, current US$) in Italy?
Keep it short and to the point. -5.77e+11. In the year 2011, what is the difference between the Imports (BoP, current US$) in Europe(all income levels) and Imports (BoP, current US$) in High income: nonOECD?
Keep it short and to the point. 6.20e+12. In the year 2011, what is the difference between the Imports (BoP, current US$) in Europe(all income levels) and Imports (BoP, current US$) in Belize?
Give a very brief answer. 8.90e+12. In the year 2011, what is the difference between the Imports (BoP, current US$) in Europe(all income levels) and Imports (BoP, current US$) in Italy?
Make the answer very short. 8.25e+12. In the year 2011, what is the difference between the Imports (BoP, current US$) of High income: nonOECD and Imports (BoP, current US$) of Belize?
Provide a short and direct response. 2.70e+12. In the year 2011, what is the difference between the Imports (BoP, current US$) in High income: nonOECD and Imports (BoP, current US$) in Italy?
Offer a terse response. 2.05e+12. In the year 2011, what is the difference between the Imports (BoP, current US$) of Belize and Imports (BoP, current US$) of Italy?
Ensure brevity in your answer.  -6.50e+11. In the year 2012, what is the difference between the Imports (BoP, current US$) of Europe(all income levels) and Imports (BoP, current US$) of High income: nonOECD?
Give a very brief answer. 5.69e+12. In the year 2012, what is the difference between the Imports (BoP, current US$) in Europe(all income levels) and Imports (BoP, current US$) in Belize?
Keep it short and to the point. 8.55e+12. In the year 2012, what is the difference between the Imports (BoP, current US$) in Europe(all income levels) and Imports (BoP, current US$) in Italy?
Make the answer very short. 7.97e+12. In the year 2012, what is the difference between the Imports (BoP, current US$) of High income: nonOECD and Imports (BoP, current US$) of Belize?
Offer a very short reply. 2.85e+12. In the year 2012, what is the difference between the Imports (BoP, current US$) in High income: nonOECD and Imports (BoP, current US$) in Italy?
Make the answer very short. 2.28e+12. In the year 2012, what is the difference between the Imports (BoP, current US$) of Belize and Imports (BoP, current US$) of Italy?
Give a very brief answer. -5.71e+11. In the year 2013, what is the difference between the Imports (BoP, current US$) of Europe(all income levels) and Imports (BoP, current US$) of High income: nonOECD?
Ensure brevity in your answer.  5.85e+12. In the year 2013, what is the difference between the Imports (BoP, current US$) of Europe(all income levels) and Imports (BoP, current US$) of Belize?
Ensure brevity in your answer.  8.84e+12. In the year 2013, what is the difference between the Imports (BoP, current US$) of Europe(all income levels) and Imports (BoP, current US$) of Italy?
Your response must be concise. 8.27e+12. In the year 2013, what is the difference between the Imports (BoP, current US$) in High income: nonOECD and Imports (BoP, current US$) in Belize?
Your response must be concise. 2.98e+12. In the year 2013, what is the difference between the Imports (BoP, current US$) in High income: nonOECD and Imports (BoP, current US$) in Italy?
Keep it short and to the point. 2.42e+12. In the year 2013, what is the difference between the Imports (BoP, current US$) of Belize and Imports (BoP, current US$) of Italy?
Ensure brevity in your answer.  -5.65e+11. In the year 2014, what is the difference between the Imports (BoP, current US$) of Europe(all income levels) and Imports (BoP, current US$) of High income: nonOECD?
Provide a short and direct response. 5.90e+12. In the year 2014, what is the difference between the Imports (BoP, current US$) in Europe(all income levels) and Imports (BoP, current US$) in Belize?
Offer a terse response. 8.88e+12. In the year 2014, what is the difference between the Imports (BoP, current US$) in Europe(all income levels) and Imports (BoP, current US$) in Italy?
Keep it short and to the point. 8.32e+12. In the year 2014, what is the difference between the Imports (BoP, current US$) in High income: nonOECD and Imports (BoP, current US$) in Belize?
Your answer should be very brief. 2.98e+12. In the year 2014, what is the difference between the Imports (BoP, current US$) in High income: nonOECD and Imports (BoP, current US$) in Italy?
Offer a very short reply. 2.42e+12. In the year 2014, what is the difference between the Imports (BoP, current US$) in Belize and Imports (BoP, current US$) in Italy?
Offer a terse response. -5.63e+11. What is the ratio of the Imports (BoP, current US$) of Europe(all income levels) in 2008 to that in 2009?
Your response must be concise. 1.3. What is the ratio of the Imports (BoP, current US$) of High income: nonOECD in 2008 to that in 2009?
Provide a short and direct response. 1.26. What is the ratio of the Imports (BoP, current US$) of Belize in 2008 to that in 2009?
Keep it short and to the point. 1.22. What is the ratio of the Imports (BoP, current US$) in Italy in 2008 to that in 2009?
Give a very brief answer. 1.32. What is the ratio of the Imports (BoP, current US$) in Europe(all income levels) in 2008 to that in 2010?
Offer a terse response. 1.16. What is the ratio of the Imports (BoP, current US$) of High income: nonOECD in 2008 to that in 2010?
Make the answer very short. 1.02. What is the ratio of the Imports (BoP, current US$) in Belize in 2008 to that in 2010?
Provide a succinct answer. 1.18. What is the ratio of the Imports (BoP, current US$) in Italy in 2008 to that in 2010?
Your answer should be very brief. 1.16. What is the ratio of the Imports (BoP, current US$) of Europe(all income levels) in 2008 to that in 2011?
Offer a terse response. 0.98. What is the ratio of the Imports (BoP, current US$) of High income: nonOECD in 2008 to that in 2011?
Your answer should be compact. 0.86. What is the ratio of the Imports (BoP, current US$) in Belize in 2008 to that in 2011?
Your answer should be very brief. 1.01. What is the ratio of the Imports (BoP, current US$) in Europe(all income levels) in 2008 to that in 2012?
Your answer should be very brief. 1.02. What is the ratio of the Imports (BoP, current US$) of High income: nonOECD in 2008 to that in 2012?
Offer a very short reply. 0.81. What is the ratio of the Imports (BoP, current US$) of Belize in 2008 to that in 2012?
Offer a terse response. 0.93. What is the ratio of the Imports (BoP, current US$) of Italy in 2008 to that in 2012?
Offer a terse response. 1.17. What is the ratio of the Imports (BoP, current US$) in High income: nonOECD in 2008 to that in 2013?
Give a very brief answer. 0.77. What is the ratio of the Imports (BoP, current US$) in Belize in 2008 to that in 2013?
Your response must be concise. 0.88. What is the ratio of the Imports (BoP, current US$) of Italy in 2008 to that in 2013?
Give a very brief answer. 1.18. What is the ratio of the Imports (BoP, current US$) in Europe(all income levels) in 2008 to that in 2014?
Offer a very short reply. 0.99. What is the ratio of the Imports (BoP, current US$) of High income: nonOECD in 2008 to that in 2014?
Offer a very short reply. 0.77. What is the ratio of the Imports (BoP, current US$) in Belize in 2008 to that in 2014?
Make the answer very short. 0.83. What is the ratio of the Imports (BoP, current US$) of Italy in 2008 to that in 2014?
Offer a very short reply. 1.18. What is the ratio of the Imports (BoP, current US$) in Europe(all income levels) in 2009 to that in 2010?
Provide a short and direct response. 0.89. What is the ratio of the Imports (BoP, current US$) in High income: nonOECD in 2009 to that in 2010?
Provide a succinct answer. 0.81. What is the ratio of the Imports (BoP, current US$) in Belize in 2009 to that in 2010?
Make the answer very short. 0.97. What is the ratio of the Imports (BoP, current US$) in Italy in 2009 to that in 2010?
Ensure brevity in your answer.  0.88. What is the ratio of the Imports (BoP, current US$) of Europe(all income levels) in 2009 to that in 2011?
Keep it short and to the point. 0.76. What is the ratio of the Imports (BoP, current US$) in High income: nonOECD in 2009 to that in 2011?
Keep it short and to the point. 0.68. What is the ratio of the Imports (BoP, current US$) of Belize in 2009 to that in 2011?
Ensure brevity in your answer.  0.82. What is the ratio of the Imports (BoP, current US$) of Italy in 2009 to that in 2011?
Your response must be concise. 0.78. What is the ratio of the Imports (BoP, current US$) in Europe(all income levels) in 2009 to that in 2012?
Make the answer very short. 0.79. What is the ratio of the Imports (BoP, current US$) of High income: nonOECD in 2009 to that in 2012?
Offer a terse response. 0.64. What is the ratio of the Imports (BoP, current US$) of Belize in 2009 to that in 2012?
Give a very brief answer. 0.76. What is the ratio of the Imports (BoP, current US$) of Italy in 2009 to that in 2012?
Make the answer very short. 0.89. What is the ratio of the Imports (BoP, current US$) in Europe(all income levels) in 2009 to that in 2013?
Ensure brevity in your answer.  0.76. What is the ratio of the Imports (BoP, current US$) of High income: nonOECD in 2009 to that in 2013?
Your response must be concise. 0.61. What is the ratio of the Imports (BoP, current US$) in Belize in 2009 to that in 2013?
Make the answer very short. 0.72. What is the ratio of the Imports (BoP, current US$) of Italy in 2009 to that in 2013?
Keep it short and to the point. 0.9. What is the ratio of the Imports (BoP, current US$) of Europe(all income levels) in 2009 to that in 2014?
Offer a very short reply. 0.76. What is the ratio of the Imports (BoP, current US$) in High income: nonOECD in 2009 to that in 2014?
Offer a very short reply. 0.61. What is the ratio of the Imports (BoP, current US$) of Belize in 2009 to that in 2014?
Give a very brief answer. 0.68. What is the ratio of the Imports (BoP, current US$) in Italy in 2009 to that in 2014?
Your response must be concise. 0.9. What is the ratio of the Imports (BoP, current US$) in Europe(all income levels) in 2010 to that in 2011?
Give a very brief answer. 0.85. What is the ratio of the Imports (BoP, current US$) of High income: nonOECD in 2010 to that in 2011?
Your answer should be very brief. 0.84. What is the ratio of the Imports (BoP, current US$) of Belize in 2010 to that in 2011?
Your response must be concise. 0.85. What is the ratio of the Imports (BoP, current US$) of Italy in 2010 to that in 2011?
Offer a terse response. 0.89. What is the ratio of the Imports (BoP, current US$) in Europe(all income levels) in 2010 to that in 2012?
Your response must be concise. 0.89. What is the ratio of the Imports (BoP, current US$) in High income: nonOECD in 2010 to that in 2012?
Give a very brief answer. 0.8. What is the ratio of the Imports (BoP, current US$) in Belize in 2010 to that in 2012?
Offer a terse response. 0.79. What is the ratio of the Imports (BoP, current US$) of Italy in 2010 to that in 2012?
Give a very brief answer. 1.01. What is the ratio of the Imports (BoP, current US$) in Europe(all income levels) in 2010 to that in 2013?
Offer a terse response. 0.86. What is the ratio of the Imports (BoP, current US$) in High income: nonOECD in 2010 to that in 2013?
Provide a short and direct response. 0.76. What is the ratio of the Imports (BoP, current US$) in Belize in 2010 to that in 2013?
Provide a succinct answer. 0.75. What is the ratio of the Imports (BoP, current US$) in Italy in 2010 to that in 2013?
Provide a succinct answer. 1.02. What is the ratio of the Imports (BoP, current US$) of Europe(all income levels) in 2010 to that in 2014?
Ensure brevity in your answer.  0.85. What is the ratio of the Imports (BoP, current US$) of High income: nonOECD in 2010 to that in 2014?
Make the answer very short. 0.76. What is the ratio of the Imports (BoP, current US$) of Belize in 2010 to that in 2014?
Your answer should be compact. 0.7. What is the ratio of the Imports (BoP, current US$) of Italy in 2010 to that in 2014?
Your answer should be compact. 1.02. What is the ratio of the Imports (BoP, current US$) in Europe(all income levels) in 2011 to that in 2012?
Make the answer very short. 1.04. What is the ratio of the Imports (BoP, current US$) of High income: nonOECD in 2011 to that in 2012?
Your response must be concise. 0.95. What is the ratio of the Imports (BoP, current US$) of Belize in 2011 to that in 2012?
Make the answer very short. 0.93. What is the ratio of the Imports (BoP, current US$) of Italy in 2011 to that in 2012?
Give a very brief answer. 1.14. What is the ratio of the Imports (BoP, current US$) in High income: nonOECD in 2011 to that in 2013?
Your answer should be very brief. 0.9. What is the ratio of the Imports (BoP, current US$) in Belize in 2011 to that in 2013?
Provide a short and direct response. 0.88. What is the ratio of the Imports (BoP, current US$) in Italy in 2011 to that in 2013?
Provide a succinct answer. 1.15. What is the ratio of the Imports (BoP, current US$) in High income: nonOECD in 2011 to that in 2014?
Ensure brevity in your answer.  0.9. What is the ratio of the Imports (BoP, current US$) in Belize in 2011 to that in 2014?
Your answer should be compact. 0.83. What is the ratio of the Imports (BoP, current US$) of Italy in 2011 to that in 2014?
Keep it short and to the point. 1.15. What is the ratio of the Imports (BoP, current US$) of Europe(all income levels) in 2012 to that in 2013?
Your answer should be very brief. 0.97. What is the ratio of the Imports (BoP, current US$) of High income: nonOECD in 2012 to that in 2013?
Provide a short and direct response. 0.96. What is the ratio of the Imports (BoP, current US$) of Belize in 2012 to that in 2013?
Your response must be concise. 0.95. What is the ratio of the Imports (BoP, current US$) in Italy in 2012 to that in 2013?
Provide a short and direct response. 1.01. What is the ratio of the Imports (BoP, current US$) of Europe(all income levels) in 2012 to that in 2014?
Your answer should be compact. 0.96. What is the ratio of the Imports (BoP, current US$) of High income: nonOECD in 2012 to that in 2014?
Make the answer very short. 0.96. What is the ratio of the Imports (BoP, current US$) in Belize in 2012 to that in 2014?
Your response must be concise. 0.89. What is the ratio of the Imports (BoP, current US$) of Belize in 2013 to that in 2014?
Your answer should be compact. 0.94. What is the ratio of the Imports (BoP, current US$) of Italy in 2013 to that in 2014?
Your response must be concise. 1. What is the difference between the highest and the second highest Imports (BoP, current US$) in Europe(all income levels)?
Provide a short and direct response. 1.32e+1. What is the difference between the highest and the second highest Imports (BoP, current US$) of High income: nonOECD?
Offer a very short reply. 1.19e+09. What is the difference between the highest and the second highest Imports (BoP, current US$) of Belize?
Your answer should be very brief. 6.64e+07. What is the difference between the highest and the second highest Imports (BoP, current US$) in Italy?
Your answer should be very brief. 1.76e+1. What is the difference between the highest and the lowest Imports (BoP, current US$) in Europe(all income levels)?
Provide a short and direct response. 2.14e+12. What is the difference between the highest and the lowest Imports (BoP, current US$) of High income: nonOECD?
Offer a very short reply. 1.15e+12. What is the difference between the highest and the lowest Imports (BoP, current US$) of Belize?
Ensure brevity in your answer.  3.68e+08. What is the difference between the highest and the lowest Imports (BoP, current US$) of Italy?
Provide a short and direct response. 1.62e+11. 